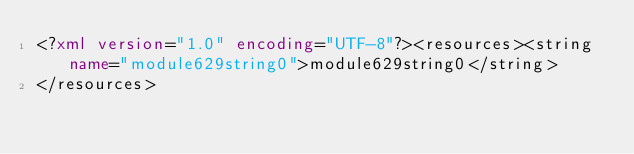Convert code to text. <code><loc_0><loc_0><loc_500><loc_500><_XML_><?xml version="1.0" encoding="UTF-8"?><resources><string name="module629string0">module629string0</string>
</resources></code> 